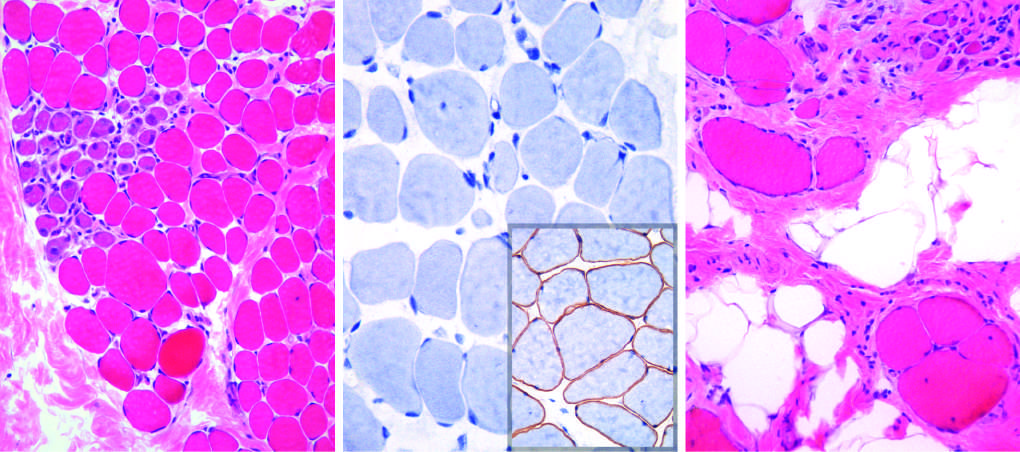s fascicular muscle architecture maintained at a younger age?
Answer the question using a single word or phrase. Yes 